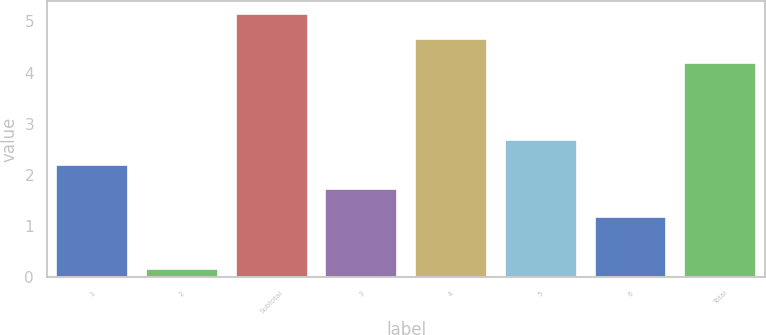<chart> <loc_0><loc_0><loc_500><loc_500><bar_chart><fcel>1<fcel>2<fcel>Subtotal<fcel>3<fcel>4<fcel>5<fcel>6<fcel>Total<nl><fcel>2.2<fcel>0.16<fcel>5.14<fcel>1.72<fcel>4.66<fcel>2.69<fcel>1.17<fcel>4.18<nl></chart> 